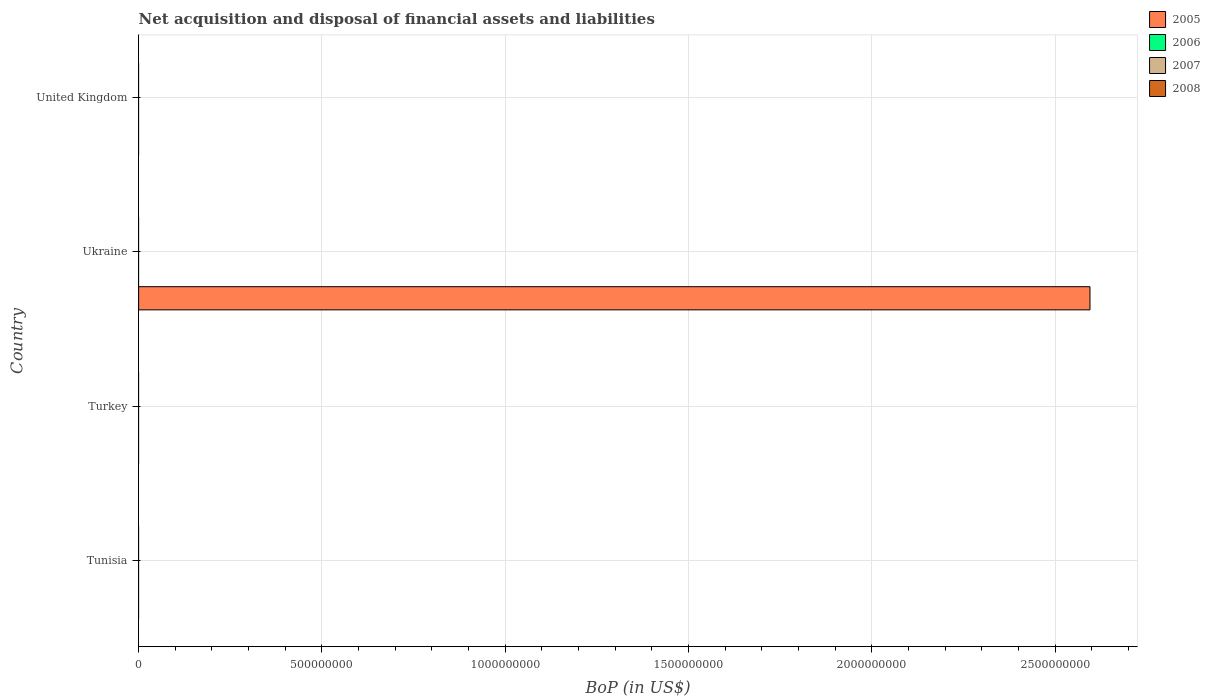How many different coloured bars are there?
Provide a short and direct response. 1. Are the number of bars per tick equal to the number of legend labels?
Offer a terse response. No. How many bars are there on the 2nd tick from the bottom?
Your response must be concise. 0. What is the difference between the Balance of Payments in 2005 in Ukraine and the Balance of Payments in 2006 in United Kingdom?
Keep it short and to the point. 2.60e+09. What is the difference between the highest and the lowest Balance of Payments in 2005?
Provide a succinct answer. 2.60e+09. Is it the case that in every country, the sum of the Balance of Payments in 2005 and Balance of Payments in 2006 is greater than the Balance of Payments in 2007?
Make the answer very short. No. Are all the bars in the graph horizontal?
Make the answer very short. Yes. How many countries are there in the graph?
Your response must be concise. 4. Are the values on the major ticks of X-axis written in scientific E-notation?
Provide a succinct answer. No. Does the graph contain any zero values?
Provide a short and direct response. Yes. What is the title of the graph?
Offer a very short reply. Net acquisition and disposal of financial assets and liabilities. What is the label or title of the X-axis?
Offer a terse response. BoP (in US$). What is the label or title of the Y-axis?
Make the answer very short. Country. What is the BoP (in US$) of 2005 in Turkey?
Ensure brevity in your answer.  0. What is the BoP (in US$) of 2006 in Turkey?
Your response must be concise. 0. What is the BoP (in US$) of 2008 in Turkey?
Keep it short and to the point. 0. What is the BoP (in US$) in 2005 in Ukraine?
Ensure brevity in your answer.  2.60e+09. What is the BoP (in US$) of 2006 in Ukraine?
Provide a succinct answer. 0. What is the BoP (in US$) in 2008 in Ukraine?
Your answer should be very brief. 0. What is the BoP (in US$) of 2006 in United Kingdom?
Provide a short and direct response. 0. What is the BoP (in US$) in 2007 in United Kingdom?
Offer a terse response. 0. Across all countries, what is the maximum BoP (in US$) in 2005?
Provide a short and direct response. 2.60e+09. What is the total BoP (in US$) of 2005 in the graph?
Give a very brief answer. 2.60e+09. What is the total BoP (in US$) of 2008 in the graph?
Your response must be concise. 0. What is the average BoP (in US$) of 2005 per country?
Make the answer very short. 6.49e+08. What is the average BoP (in US$) in 2007 per country?
Ensure brevity in your answer.  0. What is the average BoP (in US$) in 2008 per country?
Provide a short and direct response. 0. What is the difference between the highest and the lowest BoP (in US$) in 2005?
Offer a terse response. 2.60e+09. 